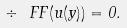<formula> <loc_0><loc_0><loc_500><loc_500>\div \ F F ( u ( y ) ) = 0 .</formula> 